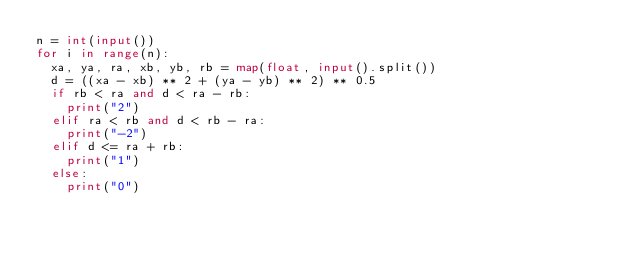<code> <loc_0><loc_0><loc_500><loc_500><_Python_>n = int(input())
for i in range(n):
  xa, ya, ra, xb, yb, rb = map(float, input().split())
  d = ((xa - xb) ** 2 + (ya - yb) ** 2) ** 0.5
  if rb < ra and d < ra - rb:
    print("2")
  elif ra < rb and d < rb - ra:
    print("-2")
  elif d <= ra + rb:
    print("1")
  else:
    print("0")
</code> 